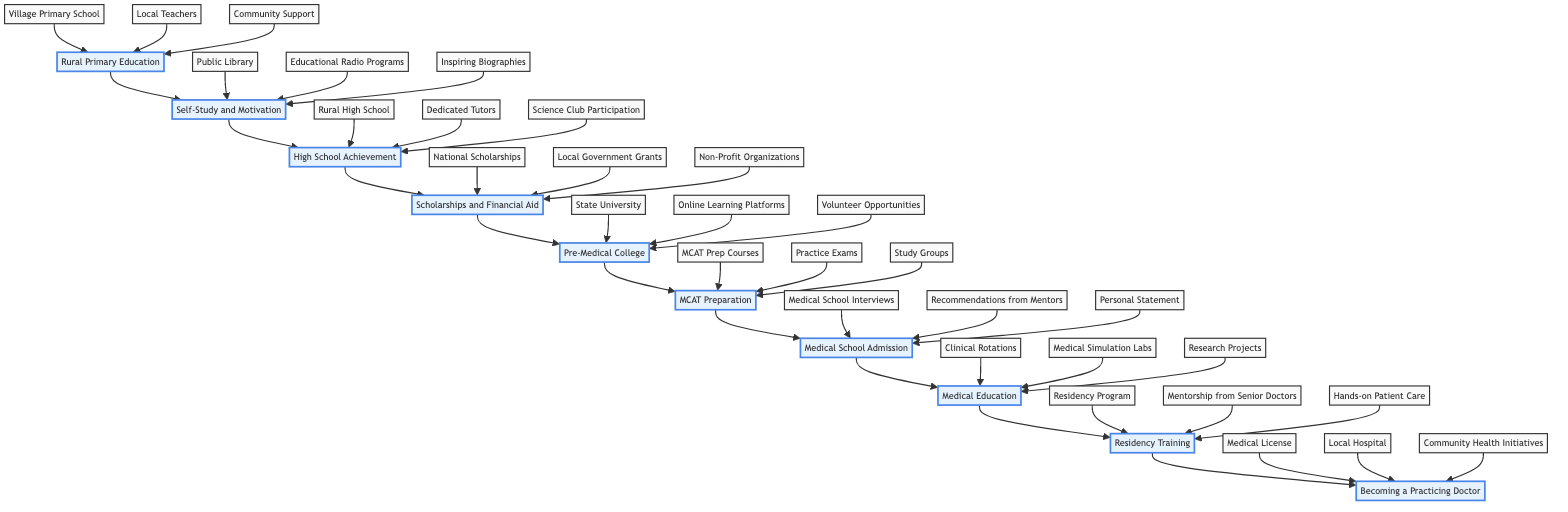What is the first step in the journey? The diagram indicates that the first step is "Rural Primary Education", which is represented by the first node in the flowchart.
Answer: Rural Primary Education How many main elements are there in the diagram? By counting the distinct main elements listed in the flowchart, we see there are ten main steps within the journey.
Answer: 10 What is the last step before "Becoming a Practicing Doctor"? The flow leads sequentially from "Residency Training" to "Becoming a Practicing Doctor", making "Residency Training" the last step before achieving the doctor status.
Answer: Residency Training Which step involves preparing for the MCAT? According to the diagram, the preparation for the MCAT is explicitly mentioned at the step labeled "MCAT Preparation".
Answer: MCAT Preparation What type of support is mentioned in the "Rural Primary Education" step? The elements associated with rural primary education include "Village Primary School", "Local Teachers", and "Community Support", all of which represent various supportive structures in that stage.
Answer: Community Support What is the relationship between "Scholarships and Financial Aid" and "Pre-Medical College"? The diagram shows that "Scholarships and Financial Aid" directly leads into "Pre-Medical College", indicating that financial support is necessary for pursuing higher education.
Answer: Directly leads into Which element focuses on gaining practical experience in medical school? The "Medical Education" step emphasizes elements like "Clinical Rotations", "Medical Simulation Labs", and "Research Projects", which all focus on gaining hands-on experience.
Answer: Medical Education What are the methods listed for self-study? The self-study methods include "Public Library", "Educational Radio Programs", and "Inspiring Biographies", which offer a range of resources for self-education.
Answer: Public Library What is emphasized in the step "Residency Training"? "Residency Training" is highlighted by key elements such as "Residency Program", "Mentorship from Senior Doctors", and "Hands-on Patient Care", indicating a focus on specialized training and practical patient interactions.
Answer: Specialized training Which support is not mentioned in the "Scholarships and Financial Aid" step? The entities listed under "Scholarships and Financial Aid" are "National Scholarships", "Local Government Grants", and "Non-Profit Organizations". Since none of these mention loans or personal savings, we can conclude those are not included.
Answer: Loans or personal savings 